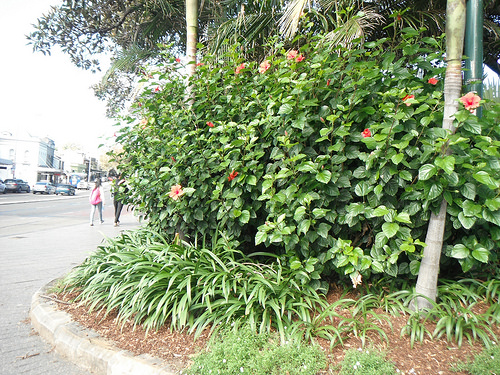<image>
Is the women in the tree? No. The women is not contained within the tree. These objects have a different spatial relationship. Where is the flower in relation to the person? Is it in front of the person? No. The flower is not in front of the person. The spatial positioning shows a different relationship between these objects. 